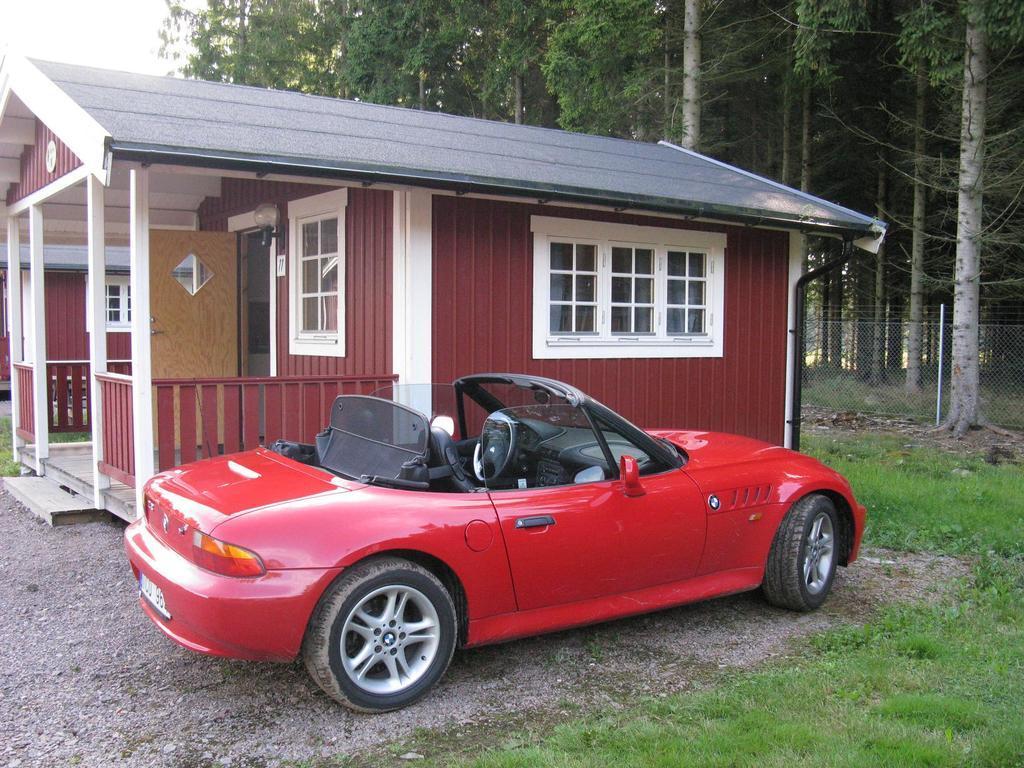In one or two sentences, can you explain what this image depicts? In this image we can see a house with roof and windows and a car which is parked beside the house. We can also see some grass, trees, a fence, bark of the tree and the sky which looks cloudy. 